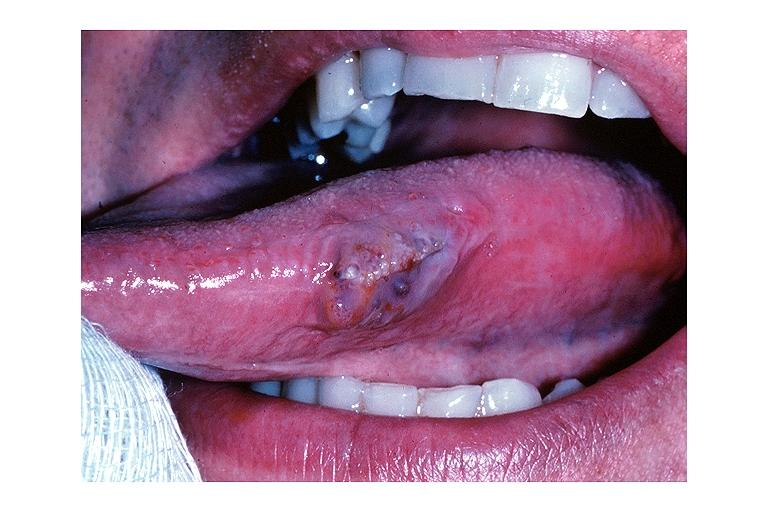s edema present?
Answer the question using a single word or phrase. No 